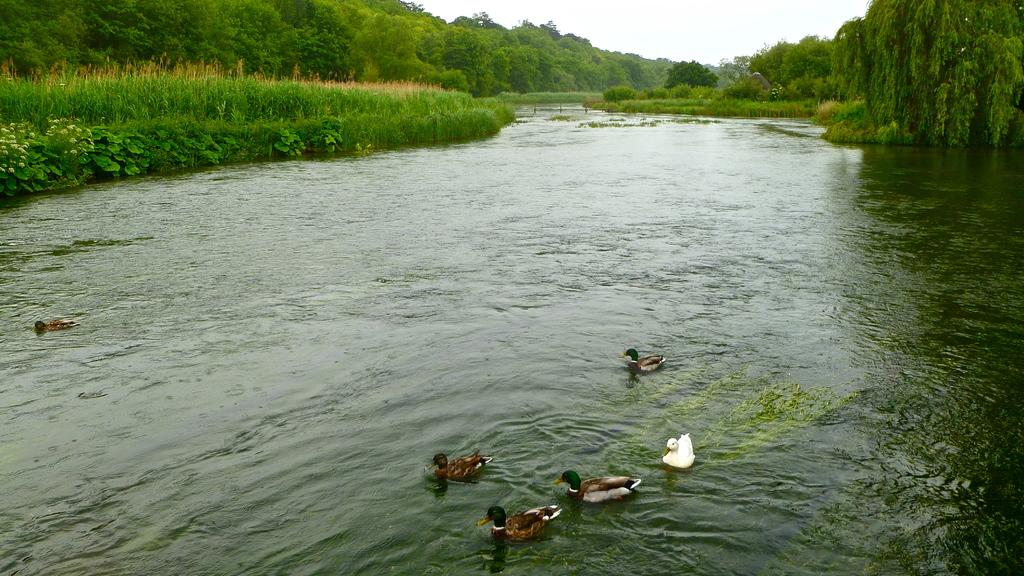What type of animals can be seen on the surface of the water in the image? There are birds on the surface of the water in the image. What type of vegetation is visible in the image? There are many trees and grass visible in the image. What part of the natural environment is visible in the image? The sky is visible in the image. How many balls can be seen in the hole in the image? There are no balls or holes present in the image. 